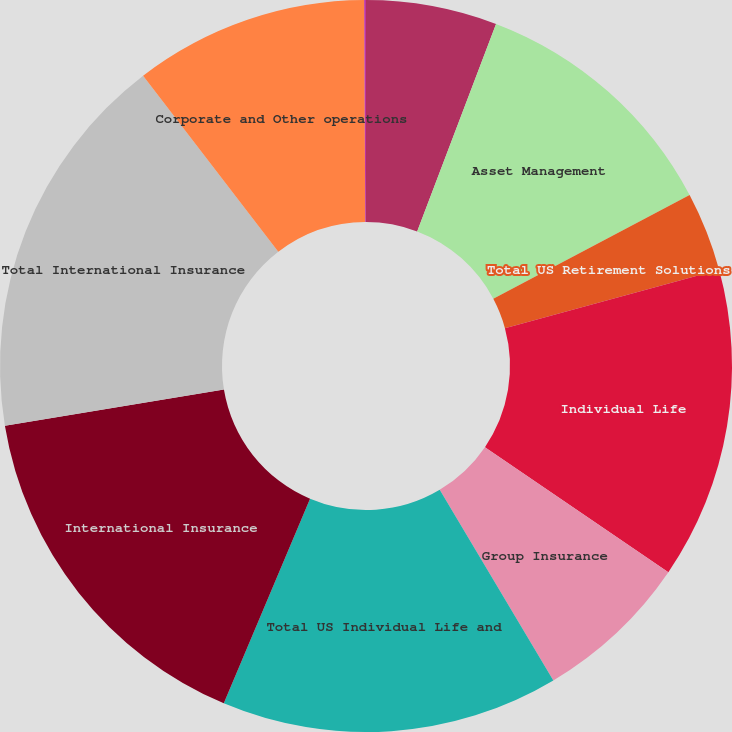Convert chart to OTSL. <chart><loc_0><loc_0><loc_500><loc_500><pie_chart><fcel>Retirement<fcel>Asset Management<fcel>Total US Retirement Solutions<fcel>Individual Life<fcel>Group Insurance<fcel>Total US Individual Life and<fcel>International Insurance<fcel>Total International Insurance<fcel>Corporate and Other operations<fcel>Total Corporate and Other<nl><fcel>5.78%<fcel>11.48%<fcel>3.5%<fcel>13.76%<fcel>6.92%<fcel>14.9%<fcel>16.04%<fcel>17.18%<fcel>10.34%<fcel>0.08%<nl></chart> 